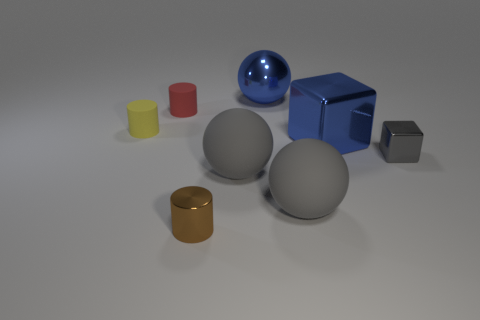What shape is the thing that is the same color as the metallic sphere?
Your response must be concise. Cube. Are there any other things that are the same color as the tiny block?
Offer a terse response. Yes. What size is the shiny thing that is behind the tiny gray metallic cube and on the left side of the large blue block?
Make the answer very short. Large. There is a tiny metal object behind the brown shiny cylinder; does it have the same color as the large shiny thing in front of the blue ball?
Offer a terse response. No. What number of other things are the same material as the red cylinder?
Your response must be concise. 3. There is a rubber object that is both to the left of the small brown cylinder and in front of the small red matte cylinder; what is its shape?
Keep it short and to the point. Cylinder. Does the small metal cylinder have the same color as the large metal thing that is behind the yellow object?
Ensure brevity in your answer.  No. Do the metal object that is on the right side of the blue metallic block and the tiny yellow rubber thing have the same size?
Offer a terse response. Yes. There is a big blue thing that is the same shape as the tiny gray metal object; what is it made of?
Offer a very short reply. Metal. Does the yellow rubber object have the same shape as the tiny gray metallic object?
Make the answer very short. No. 